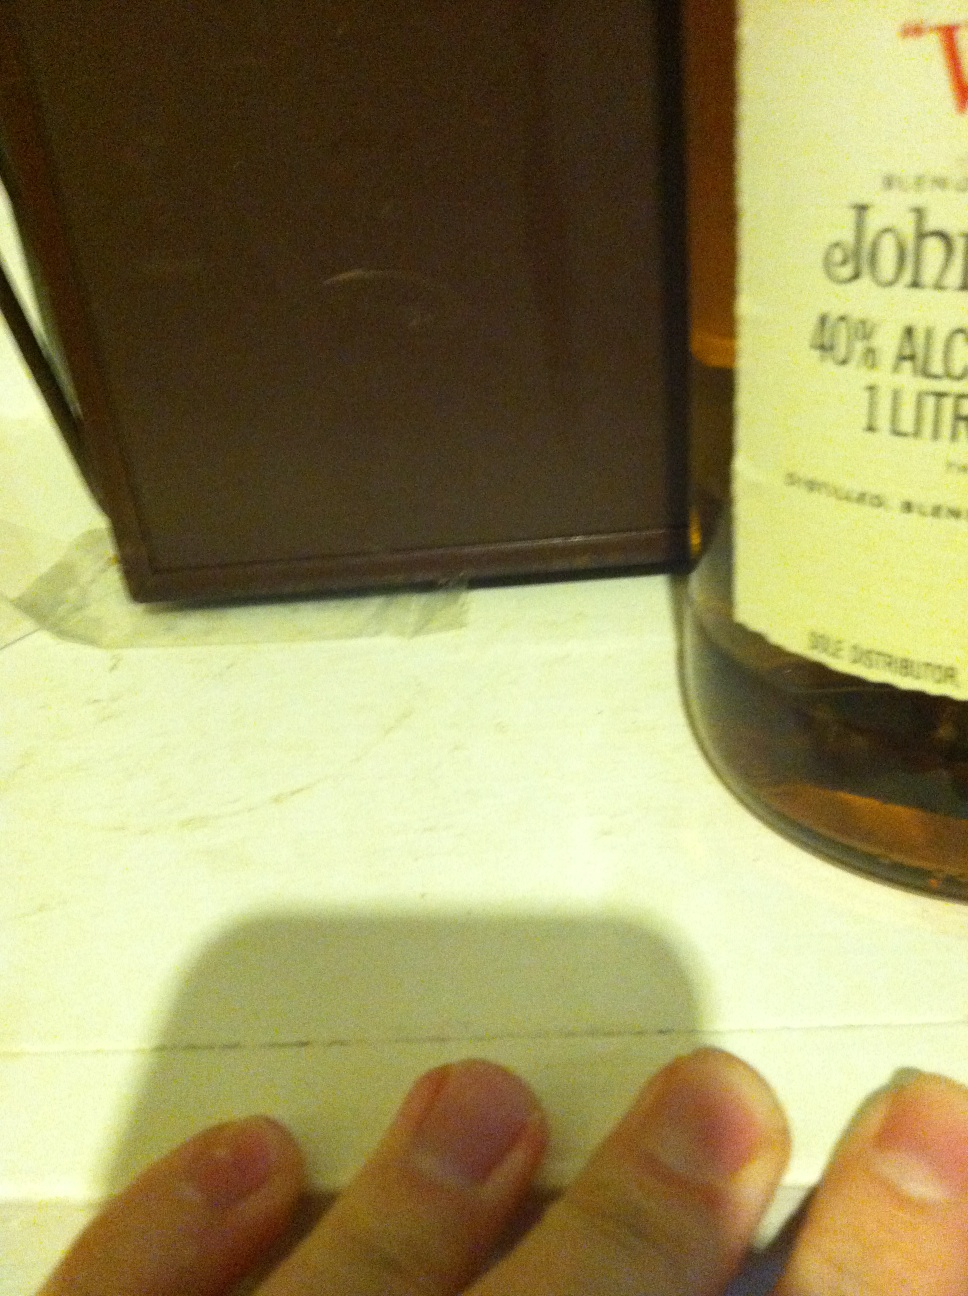What kind of environment do you think this whisky is best enjoyed in? This whisky would be best enjoyed in a cozy, intimate setting where one can fully appreciate its flavors and aromas. Picture a quiet evening by the fireplace, in a dimly lit room with the soft sound of jazz or classical music playing in the background. It could also be a perfect choice for a gathering of friends, where stories and laughter flow as freely as the drinks. 